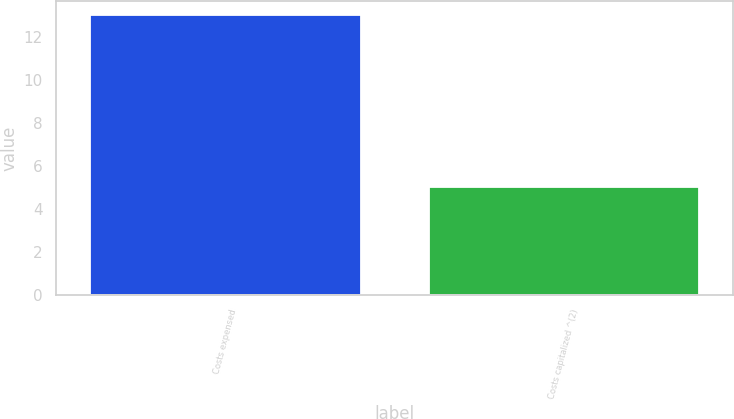Convert chart to OTSL. <chart><loc_0><loc_0><loc_500><loc_500><bar_chart><fcel>Costs expensed<fcel>Costs capitalized ^(2)<nl><fcel>13<fcel>5<nl></chart> 